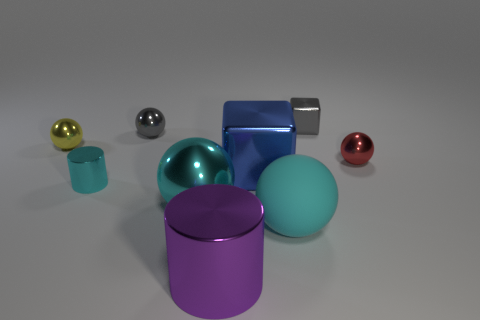Subtract all yellow balls. How many balls are left? 4 Subtract all red spheres. How many spheres are left? 4 Subtract all green spheres. Subtract all cyan cubes. How many spheres are left? 5 Add 1 large brown matte objects. How many objects exist? 10 Subtract all cylinders. How many objects are left? 7 Subtract 1 gray balls. How many objects are left? 8 Subtract all big cylinders. Subtract all small yellow shiny balls. How many objects are left? 7 Add 2 large objects. How many large objects are left? 6 Add 6 small yellow metallic balls. How many small yellow metallic balls exist? 7 